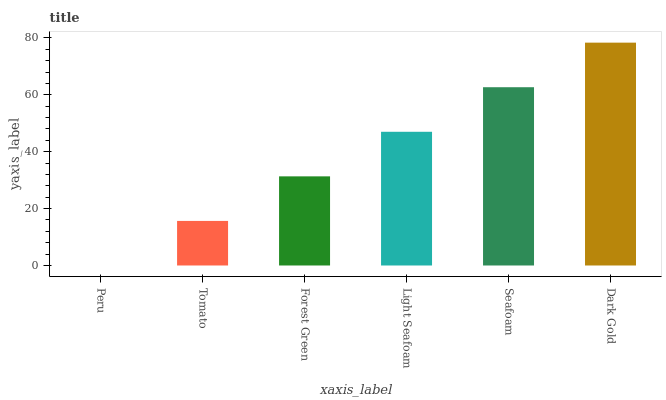Is Peru the minimum?
Answer yes or no. Yes. Is Dark Gold the maximum?
Answer yes or no. Yes. Is Tomato the minimum?
Answer yes or no. No. Is Tomato the maximum?
Answer yes or no. No. Is Tomato greater than Peru?
Answer yes or no. Yes. Is Peru less than Tomato?
Answer yes or no. Yes. Is Peru greater than Tomato?
Answer yes or no. No. Is Tomato less than Peru?
Answer yes or no. No. Is Light Seafoam the high median?
Answer yes or no. Yes. Is Forest Green the low median?
Answer yes or no. Yes. Is Seafoam the high median?
Answer yes or no. No. Is Dark Gold the low median?
Answer yes or no. No. 